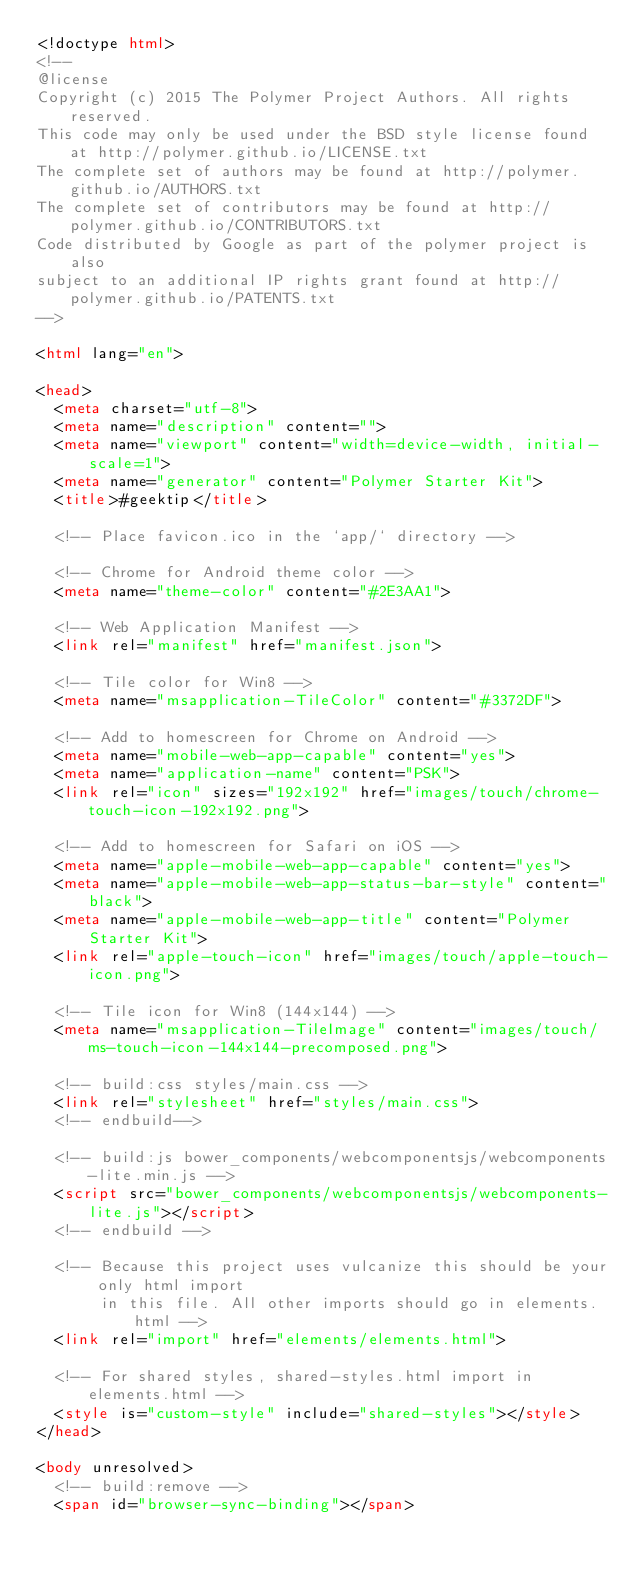<code> <loc_0><loc_0><loc_500><loc_500><_HTML_><!doctype html>
<!--
@license
Copyright (c) 2015 The Polymer Project Authors. All rights reserved.
This code may only be used under the BSD style license found at http://polymer.github.io/LICENSE.txt
The complete set of authors may be found at http://polymer.github.io/AUTHORS.txt
The complete set of contributors may be found at http://polymer.github.io/CONTRIBUTORS.txt
Code distributed by Google as part of the polymer project is also
subject to an additional IP rights grant found at http://polymer.github.io/PATENTS.txt
-->

<html lang="en">

<head>
  <meta charset="utf-8">
  <meta name="description" content="">
  <meta name="viewport" content="width=device-width, initial-scale=1">
  <meta name="generator" content="Polymer Starter Kit">
  <title>#geektip</title>

  <!-- Place favicon.ico in the `app/` directory -->

  <!-- Chrome for Android theme color -->
  <meta name="theme-color" content="#2E3AA1">

  <!-- Web Application Manifest -->
  <link rel="manifest" href="manifest.json">

  <!-- Tile color for Win8 -->
  <meta name="msapplication-TileColor" content="#3372DF">

  <!-- Add to homescreen for Chrome on Android -->
  <meta name="mobile-web-app-capable" content="yes">
  <meta name="application-name" content="PSK">
  <link rel="icon" sizes="192x192" href="images/touch/chrome-touch-icon-192x192.png">

  <!-- Add to homescreen for Safari on iOS -->
  <meta name="apple-mobile-web-app-capable" content="yes">
  <meta name="apple-mobile-web-app-status-bar-style" content="black">
  <meta name="apple-mobile-web-app-title" content="Polymer Starter Kit">
  <link rel="apple-touch-icon" href="images/touch/apple-touch-icon.png">

  <!-- Tile icon for Win8 (144x144) -->
  <meta name="msapplication-TileImage" content="images/touch/ms-touch-icon-144x144-precomposed.png">

  <!-- build:css styles/main.css -->
  <link rel="stylesheet" href="styles/main.css">
  <!-- endbuild-->

  <!-- build:js bower_components/webcomponentsjs/webcomponents-lite.min.js -->
  <script src="bower_components/webcomponentsjs/webcomponents-lite.js"></script>
  <!-- endbuild -->

  <!-- Because this project uses vulcanize this should be your only html import
       in this file. All other imports should go in elements.html -->
  <link rel="import" href="elements/elements.html">

  <!-- For shared styles, shared-styles.html import in elements.html -->
  <style is="custom-style" include="shared-styles"></style>
</head>

<body unresolved>
  <!-- build:remove -->
  <span id="browser-sync-binding"></span></code> 